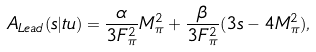Convert formula to latex. <formula><loc_0><loc_0><loc_500><loc_500>A _ { L e a d } ( s | t u ) = \frac { \alpha } { 3 F _ { \pi } ^ { 2 } } M _ { \pi } ^ { 2 } + \frac { \beta } { 3 F _ { \pi } ^ { 2 } } ( 3 s - 4 M _ { \pi } ^ { 2 } ) ,</formula> 